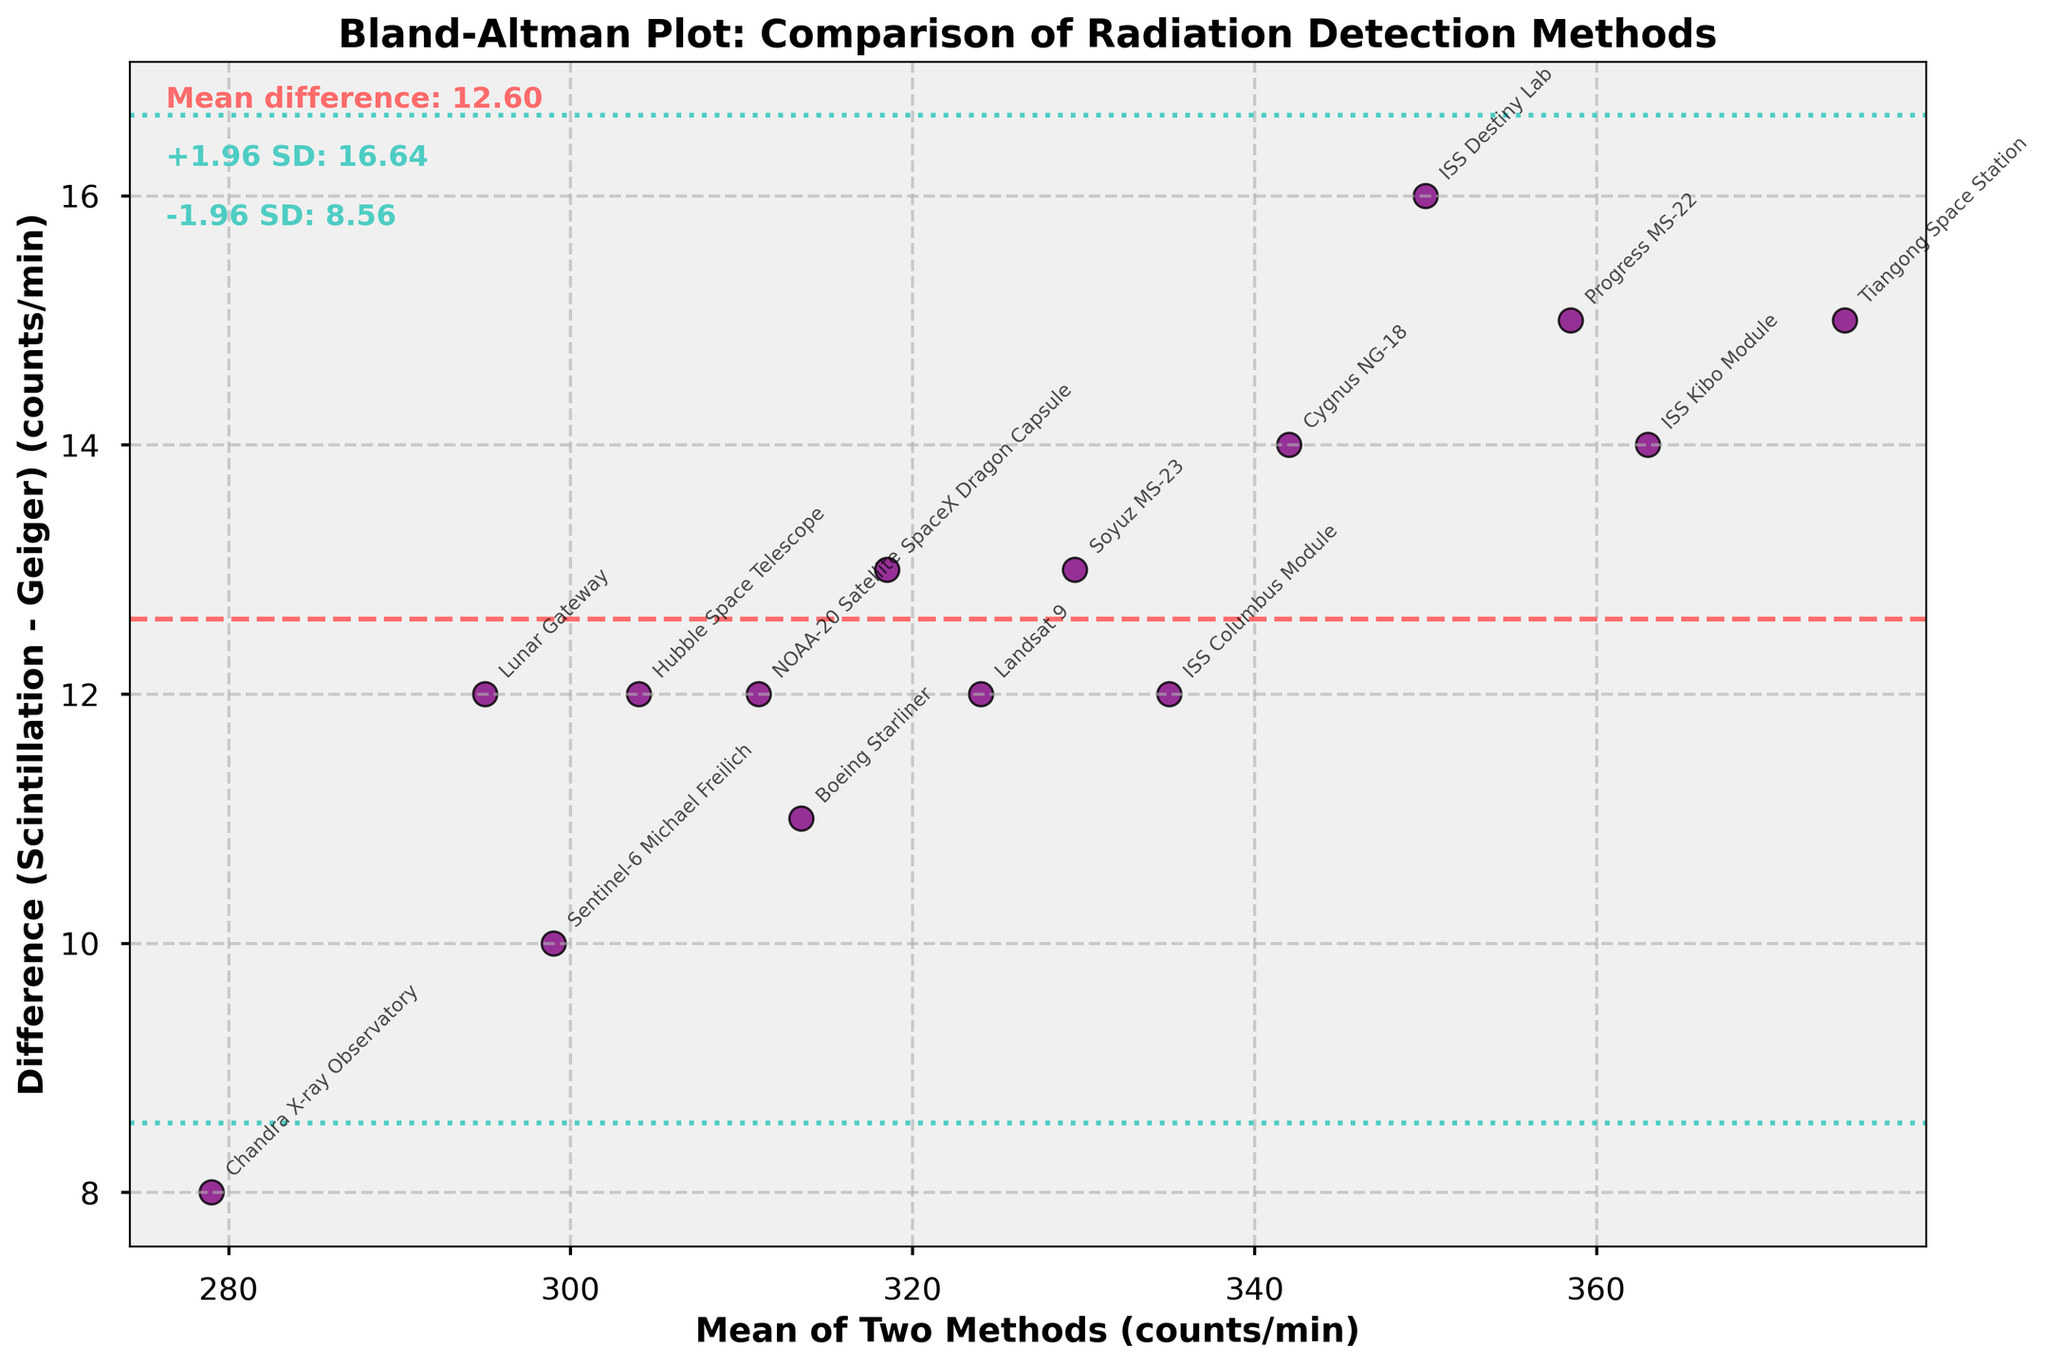What is the title of the plot? The title of the plot is typically found at the top and can be read directly.
Answer: Bland-Altman Plot: Comparison of Radiation Detection Methods How many data points are plotted in this figure? To determine the number of data points, count the individual data points shown in the scatter plot.
Answer: 15 What is the mean difference between the two radiation detection methods? This value is labeled on the graph as "Mean difference" and can be read directly.
Answer: 12.07 What are the limits of agreement (±1.96 SD) for the differences? The limits of agreement are labeled on the graph as "+1.96 SD" and "-1.96 SD" and can be read directly.
Answer: -0.54 and 24.68 Which instruments show the largest positive difference between the two methods? Find the data point with the highest vertical position above the zero line on the y-axis and read the label.
Answer: Tiangong Space Station Which instruments show the largest negative difference between the two methods? Find the data point with the lowest vertical position below the zero line on the y-axis and read the label.
Answer: Chandra X-ray Observatory What is the mean of the readings for the ISS Columbus Module? The mean value is calculated as (Geiger + Scintillation) / 2, which for ISS Columbus Module is (329 + 341) / 2. So, (329 + 341)/2 = 335.
Answer: 335 Are most of the differences within the limits of agreement? Visually inspect how many points fall within the horizontal lines labeled ±1.96 SD.
Answer: Yes Which instrument has a mean of around 300 counts/min? Find the data point close to 300 on the x-axis and read the label. Multiple data points might be around this value, so identify the closest one.
Answer: Hubble Space Telescope Is there any observable trend in differences based on mean count rates? Visually inspect if the differences increase or decrease systematically with the mean count rates.
Answer: No observable trend 